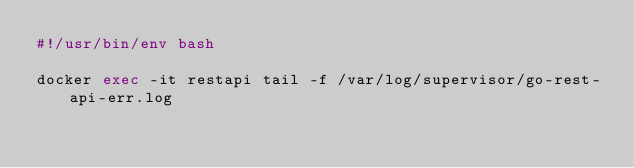Convert code to text. <code><loc_0><loc_0><loc_500><loc_500><_Bash_>#!/usr/bin/env bash

docker exec -it restapi tail -f /var/log/supervisor/go-rest-api-err.log
</code> 